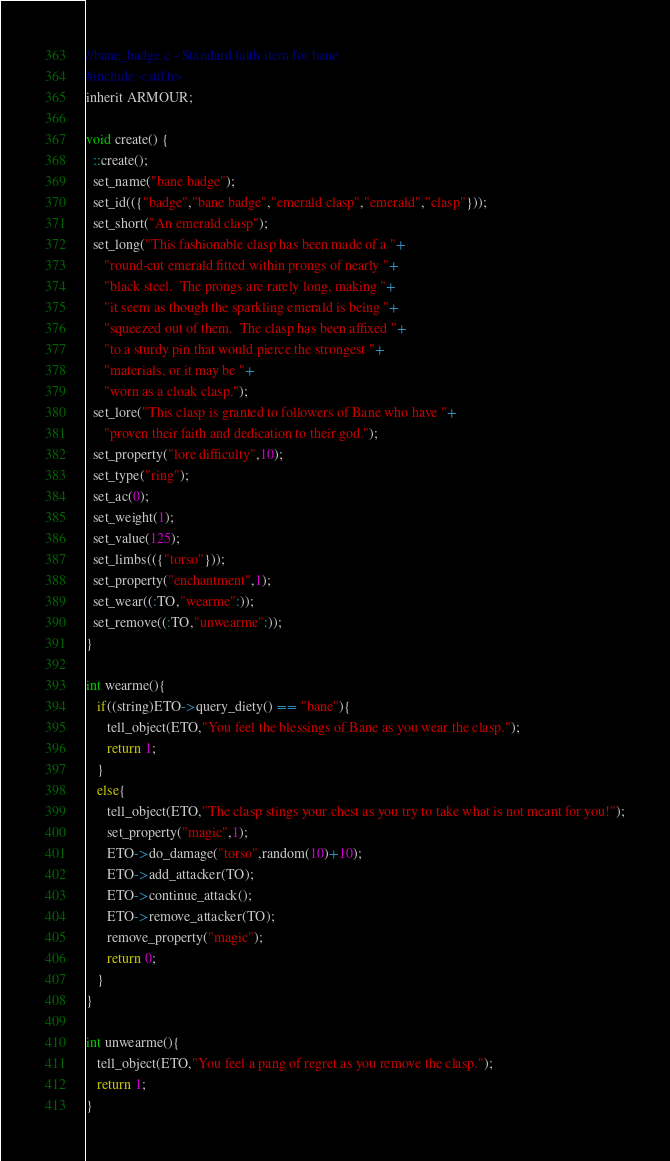Convert code to text. <code><loc_0><loc_0><loc_500><loc_500><_C_>//bane_badge.c - Standard faith item for bane
#include <std.h>
inherit ARMOUR;

void create() {
  ::create();
  set_name("bane badge");                        
  set_id(({"badge","bane badge","emerald clasp","emerald","clasp"}));
  set_short("An emerald clasp");   
  set_long("This fashionable clasp has been made of a "+
     "round-cut emerald fitted within prongs of nearly "+
     "black steel.  The prongs are rarely long, making "+
     "it seem as though the sparkling emerald is being "+
     "squeezed out of them.  The clasp has been affixed "+
     "to a sturdy pin that would pierce the strongest "+
     "materials, or it may be "+
     "worn as a cloak clasp.");
  set_lore("This clasp is granted to followers of Bane who have "+
     "proven their faith and dedication to their god.");
  set_property("lore difficulty",10);
  set_type("ring");
  set_ac(0);  
  set_weight(1);
  set_value(125);
  set_limbs(({"torso"}));
  set_property("enchantment",1);
  set_wear((:TO,"wearme":));      
  set_remove((:TO,"unwearme":));
}

int wearme(){
   if((string)ETO->query_diety() == "bane"){
      tell_object(ETO,"You feel the blessings of Bane as you wear the clasp.");
      return 1;
   }
   else{
      tell_object(ETO,"The clasp stings your chest as you try to take what is not meant for you!");
      set_property("magic",1);
      ETO->do_damage("torso",random(10)+10);
      ETO->add_attacker(TO);
      ETO->continue_attack();
      ETO->remove_attacker(TO);
      remove_property("magic");
      return 0;
   }
}

int unwearme(){
   tell_object(ETO,"You feel a pang of regret as you remove the clasp.");
   return 1;
}
</code> 